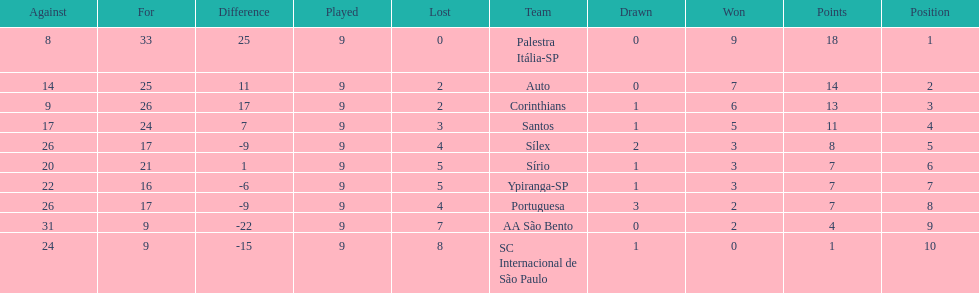In 1926 brazilian football,aside from the first place team, what other teams had winning records? Auto, Corinthians, Santos. Can you give me this table as a dict? {'header': ['Against', 'For', 'Difference', 'Played', 'Lost', 'Team', 'Drawn', 'Won', 'Points', 'Position'], 'rows': [['8', '33', '25', '9', '0', 'Palestra Itália-SP', '0', '9', '18', '1'], ['14', '25', '11', '9', '2', 'Auto', '0', '7', '14', '2'], ['9', '26', '17', '9', '2', 'Corinthians', '1', '6', '13', '3'], ['17', '24', '7', '9', '3', 'Santos', '1', '5', '11', '4'], ['26', '17', '-9', '9', '4', 'Sílex', '2', '3', '8', '5'], ['20', '21', '1', '9', '5', 'Sírio', '1', '3', '7', '6'], ['22', '16', '-6', '9', '5', 'Ypiranga-SP', '1', '3', '7', '7'], ['26', '17', '-9', '9', '4', 'Portuguesa', '3', '2', '7', '8'], ['31', '9', '-22', '9', '7', 'AA São Bento', '0', '2', '4', '9'], ['24', '9', '-15', '9', '8', 'SC Internacional de São Paulo', '1', '0', '1', '10']]} 